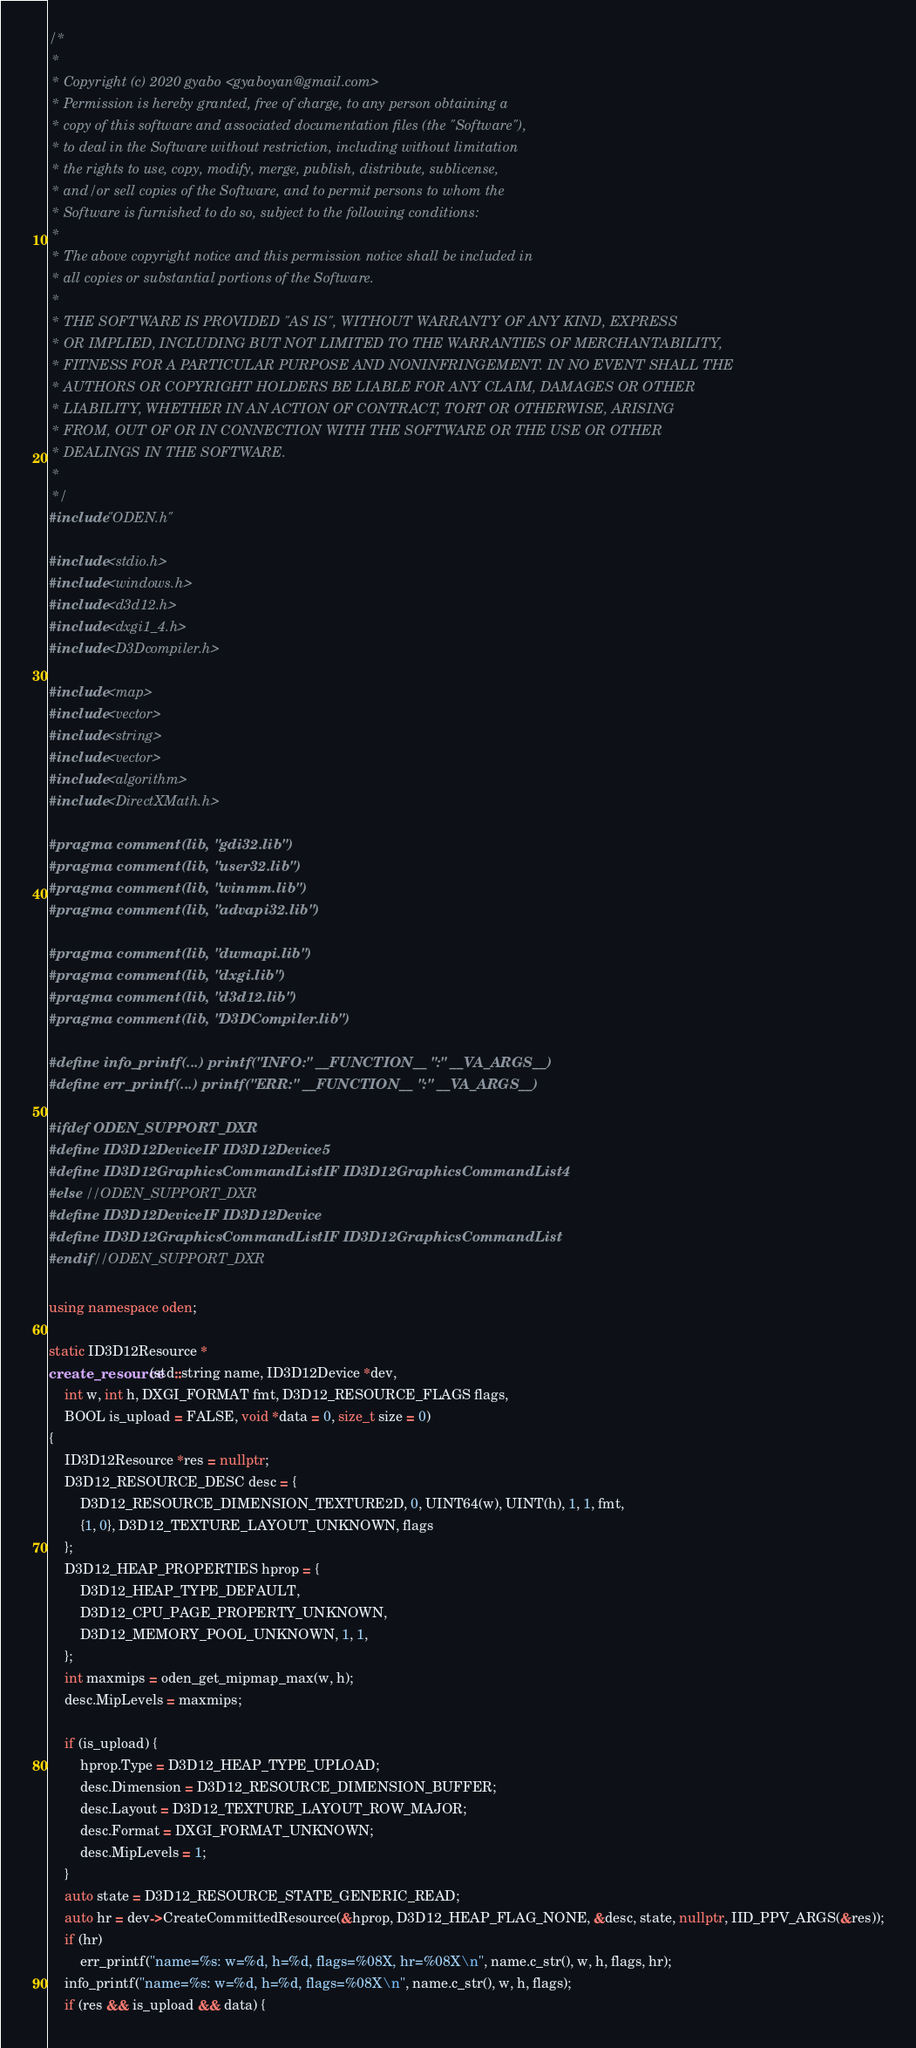Convert code to text. <code><loc_0><loc_0><loc_500><loc_500><_C++_>/*
 *
 * Copyright (c) 2020 gyabo <gyaboyan@gmail.com>
 * Permission is hereby granted, free of charge, to any person obtaining a
 * copy of this software and associated documentation files (the "Software"),
 * to deal in the Software without restriction, including without limitation
 * the rights to use, copy, modify, merge, publish, distribute, sublicense,
 * and/or sell copies of the Software, and to permit persons to whom the
 * Software is furnished to do so, subject to the following conditions:
 *
 * The above copyright notice and this permission notice shall be included in
 * all copies or substantial portions of the Software.
 *
 * THE SOFTWARE IS PROVIDED "AS IS", WITHOUT WARRANTY OF ANY KIND, EXPRESS
 * OR IMPLIED, INCLUDING BUT NOT LIMITED TO THE WARRANTIES OF MERCHANTABILITY,
 * FITNESS FOR A PARTICULAR PURPOSE AND NONINFRINGEMENT. IN NO EVENT SHALL THE
 * AUTHORS OR COPYRIGHT HOLDERS BE LIABLE FOR ANY CLAIM, DAMAGES OR OTHER
 * LIABILITY, WHETHER IN AN ACTION OF CONTRACT, TORT OR OTHERWISE, ARISING
 * FROM, OUT OF OR IN CONNECTION WITH THE SOFTWARE OR THE USE OR OTHER
 * DEALINGS IN THE SOFTWARE.
 *
 */
#include "ODEN.h"

#include <stdio.h>
#include <windows.h>
#include <d3d12.h>
#include <dxgi1_4.h>
#include <D3Dcompiler.h>

#include <map>
#include <vector>
#include <string>
#include <vector>
#include <algorithm>
#include <DirectXMath.h>

#pragma comment(lib, "gdi32.lib")
#pragma comment(lib, "user32.lib")
#pragma comment(lib, "winmm.lib")
#pragma comment(lib, "advapi32.lib")

#pragma comment(lib, "dwmapi.lib")
#pragma comment(lib, "dxgi.lib")
#pragma comment(lib, "d3d12.lib")
#pragma comment(lib, "D3DCompiler.lib")

#define info_printf(...) printf("INFO:" __FUNCTION__ ":" __VA_ARGS__)
#define err_printf(...) printf("ERR:" __FUNCTION__ ":" __VA_ARGS__)

#ifdef ODEN_SUPPORT_DXR
#define ID3D12DeviceIF ID3D12Device5
#define ID3D12GraphicsCommandListIF ID3D12GraphicsCommandList4
#else //ODEN_SUPPORT_DXR
#define ID3D12DeviceIF ID3D12Device
#define ID3D12GraphicsCommandListIF ID3D12GraphicsCommandList
#endif //ODEN_SUPPORT_DXR

using namespace oden;

static ID3D12Resource *
create_resource(std::string name, ID3D12Device *dev,
	int w, int h, DXGI_FORMAT fmt, D3D12_RESOURCE_FLAGS flags,
	BOOL is_upload = FALSE, void *data = 0, size_t size = 0)
{
	ID3D12Resource *res = nullptr;
	D3D12_RESOURCE_DESC desc = {
		D3D12_RESOURCE_DIMENSION_TEXTURE2D, 0, UINT64(w), UINT(h), 1, 1, fmt,
		{1, 0}, D3D12_TEXTURE_LAYOUT_UNKNOWN, flags
	};
	D3D12_HEAP_PROPERTIES hprop = {
		D3D12_HEAP_TYPE_DEFAULT,
		D3D12_CPU_PAGE_PROPERTY_UNKNOWN,
		D3D12_MEMORY_POOL_UNKNOWN, 1, 1,
	};
	int maxmips = oden_get_mipmap_max(w, h);
	desc.MipLevels = maxmips;

	if (is_upload) {
		hprop.Type = D3D12_HEAP_TYPE_UPLOAD;
		desc.Dimension = D3D12_RESOURCE_DIMENSION_BUFFER;
		desc.Layout = D3D12_TEXTURE_LAYOUT_ROW_MAJOR;
		desc.Format = DXGI_FORMAT_UNKNOWN;
		desc.MipLevels = 1;
	}
	auto state = D3D12_RESOURCE_STATE_GENERIC_READ;
	auto hr = dev->CreateCommittedResource(&hprop, D3D12_HEAP_FLAG_NONE, &desc, state, nullptr, IID_PPV_ARGS(&res));
	if (hr)
		err_printf("name=%s: w=%d, h=%d, flags=%08X, hr=%08X\n", name.c_str(), w, h, flags, hr);
	info_printf("name=%s: w=%d, h=%d, flags=%08X\n", name.c_str(), w, h, flags);
	if (res && is_upload && data) {</code> 